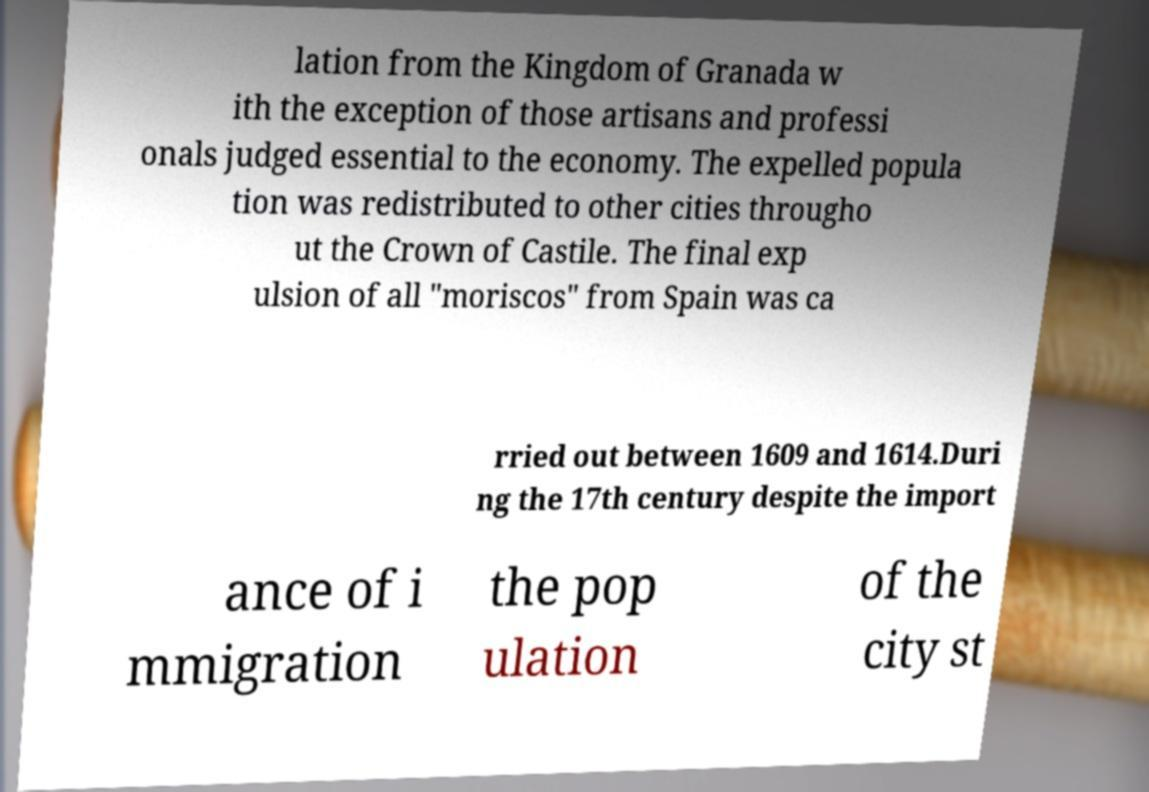Can you read and provide the text displayed in the image?This photo seems to have some interesting text. Can you extract and type it out for me? lation from the Kingdom of Granada w ith the exception of those artisans and professi onals judged essential to the economy. The expelled popula tion was redistributed to other cities througho ut the Crown of Castile. The final exp ulsion of all "moriscos" from Spain was ca rried out between 1609 and 1614.Duri ng the 17th century despite the import ance of i mmigration the pop ulation of the city st 